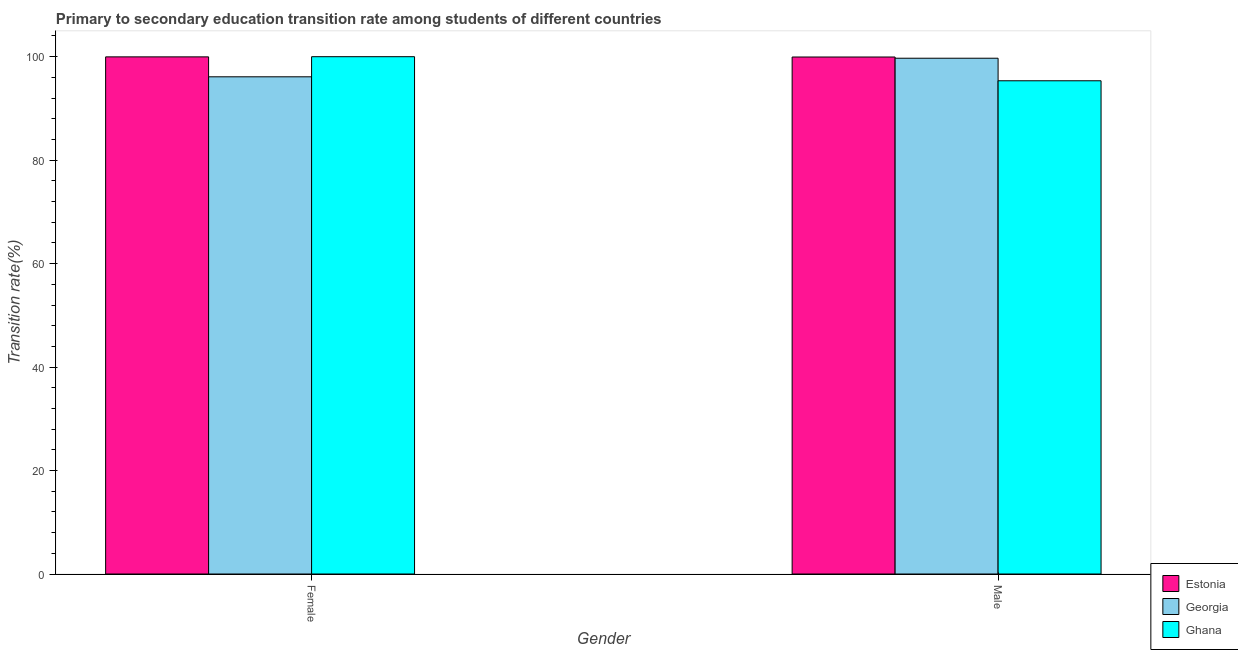How many groups of bars are there?
Provide a short and direct response. 2. How many bars are there on the 1st tick from the left?
Your answer should be compact. 3. What is the label of the 1st group of bars from the left?
Your answer should be very brief. Female. What is the transition rate among male students in Georgia?
Ensure brevity in your answer.  99.7. Across all countries, what is the maximum transition rate among male students?
Make the answer very short. 99.94. Across all countries, what is the minimum transition rate among female students?
Ensure brevity in your answer.  96.11. In which country was the transition rate among male students maximum?
Ensure brevity in your answer.  Estonia. In which country was the transition rate among male students minimum?
Give a very brief answer. Ghana. What is the total transition rate among male students in the graph?
Your answer should be very brief. 294.99. What is the difference between the transition rate among male students in Georgia and that in Estonia?
Give a very brief answer. -0.23. What is the difference between the transition rate among male students in Ghana and the transition rate among female students in Georgia?
Offer a terse response. -0.77. What is the average transition rate among male students per country?
Your response must be concise. 98.33. What is the difference between the transition rate among male students and transition rate among female students in Ghana?
Offer a terse response. -4.66. In how many countries, is the transition rate among male students greater than 20 %?
Offer a terse response. 3. What is the ratio of the transition rate among female students in Ghana to that in Estonia?
Make the answer very short. 1. In how many countries, is the transition rate among female students greater than the average transition rate among female students taken over all countries?
Provide a succinct answer. 2. What does the 2nd bar from the left in Female represents?
Offer a terse response. Georgia. What does the 2nd bar from the right in Female represents?
Ensure brevity in your answer.  Georgia. How many bars are there?
Keep it short and to the point. 6. Are all the bars in the graph horizontal?
Offer a terse response. No. How many countries are there in the graph?
Make the answer very short. 3. Are the values on the major ticks of Y-axis written in scientific E-notation?
Keep it short and to the point. No. Does the graph contain grids?
Offer a very short reply. No. Where does the legend appear in the graph?
Offer a terse response. Bottom right. How many legend labels are there?
Provide a short and direct response. 3. What is the title of the graph?
Ensure brevity in your answer.  Primary to secondary education transition rate among students of different countries. What is the label or title of the Y-axis?
Provide a short and direct response. Transition rate(%). What is the Transition rate(%) in Estonia in Female?
Your answer should be compact. 99.97. What is the Transition rate(%) of Georgia in Female?
Your response must be concise. 96.11. What is the Transition rate(%) in Estonia in Male?
Keep it short and to the point. 99.94. What is the Transition rate(%) of Georgia in Male?
Provide a succinct answer. 99.7. What is the Transition rate(%) in Ghana in Male?
Offer a terse response. 95.34. Across all Gender, what is the maximum Transition rate(%) of Estonia?
Your answer should be very brief. 99.97. Across all Gender, what is the maximum Transition rate(%) in Georgia?
Offer a very short reply. 99.7. Across all Gender, what is the maximum Transition rate(%) of Ghana?
Your response must be concise. 100. Across all Gender, what is the minimum Transition rate(%) of Estonia?
Make the answer very short. 99.94. Across all Gender, what is the minimum Transition rate(%) of Georgia?
Your answer should be compact. 96.11. Across all Gender, what is the minimum Transition rate(%) of Ghana?
Your response must be concise. 95.34. What is the total Transition rate(%) in Estonia in the graph?
Offer a very short reply. 199.9. What is the total Transition rate(%) of Georgia in the graph?
Your response must be concise. 195.82. What is the total Transition rate(%) of Ghana in the graph?
Provide a succinct answer. 195.34. What is the difference between the Transition rate(%) of Estonia in Female and that in Male?
Your answer should be very brief. 0.03. What is the difference between the Transition rate(%) of Georgia in Female and that in Male?
Keep it short and to the point. -3.59. What is the difference between the Transition rate(%) of Ghana in Female and that in Male?
Your answer should be compact. 4.66. What is the difference between the Transition rate(%) in Estonia in Female and the Transition rate(%) in Georgia in Male?
Give a very brief answer. 0.26. What is the difference between the Transition rate(%) in Estonia in Female and the Transition rate(%) in Ghana in Male?
Provide a succinct answer. 4.62. What is the difference between the Transition rate(%) of Georgia in Female and the Transition rate(%) of Ghana in Male?
Ensure brevity in your answer.  0.77. What is the average Transition rate(%) in Estonia per Gender?
Offer a very short reply. 99.95. What is the average Transition rate(%) of Georgia per Gender?
Keep it short and to the point. 97.91. What is the average Transition rate(%) in Ghana per Gender?
Offer a very short reply. 97.67. What is the difference between the Transition rate(%) in Estonia and Transition rate(%) in Georgia in Female?
Keep it short and to the point. 3.86. What is the difference between the Transition rate(%) of Estonia and Transition rate(%) of Ghana in Female?
Your answer should be compact. -0.03. What is the difference between the Transition rate(%) of Georgia and Transition rate(%) of Ghana in Female?
Provide a succinct answer. -3.89. What is the difference between the Transition rate(%) of Estonia and Transition rate(%) of Georgia in Male?
Give a very brief answer. 0.23. What is the difference between the Transition rate(%) of Estonia and Transition rate(%) of Ghana in Male?
Your answer should be very brief. 4.59. What is the difference between the Transition rate(%) of Georgia and Transition rate(%) of Ghana in Male?
Give a very brief answer. 4.36. What is the ratio of the Transition rate(%) in Ghana in Female to that in Male?
Keep it short and to the point. 1.05. What is the difference between the highest and the second highest Transition rate(%) of Estonia?
Give a very brief answer. 0.03. What is the difference between the highest and the second highest Transition rate(%) in Georgia?
Provide a short and direct response. 3.59. What is the difference between the highest and the second highest Transition rate(%) in Ghana?
Your answer should be very brief. 4.66. What is the difference between the highest and the lowest Transition rate(%) in Estonia?
Ensure brevity in your answer.  0.03. What is the difference between the highest and the lowest Transition rate(%) in Georgia?
Keep it short and to the point. 3.59. What is the difference between the highest and the lowest Transition rate(%) of Ghana?
Keep it short and to the point. 4.66. 